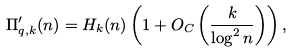<formula> <loc_0><loc_0><loc_500><loc_500>\Pi ^ { \prime } _ { q , k } ( n ) = H _ { k } ( n ) \left ( 1 + O _ { C } \left ( \frac { k } { \log ^ { 2 } n } \right ) \right ) ,</formula> 